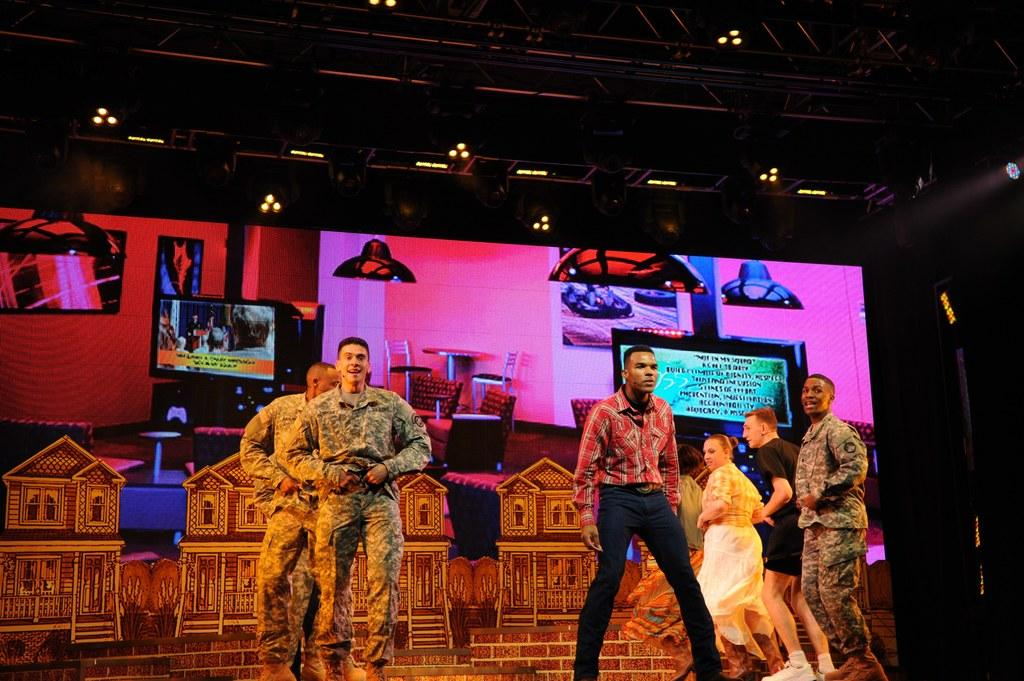How many people are in the image? There is a group of people in the image, but the exact number is not specified. What are some of the people wearing? Some of the people in the image are wearing uniforms. What can be seen in the background of the image? There is a screen and lights on the ceiling in the background of the image. What type of flame can be seen coming from the leg of one of the people in the image? There is no flame present in the image, nor is there any indication that a person's leg is on fire. 